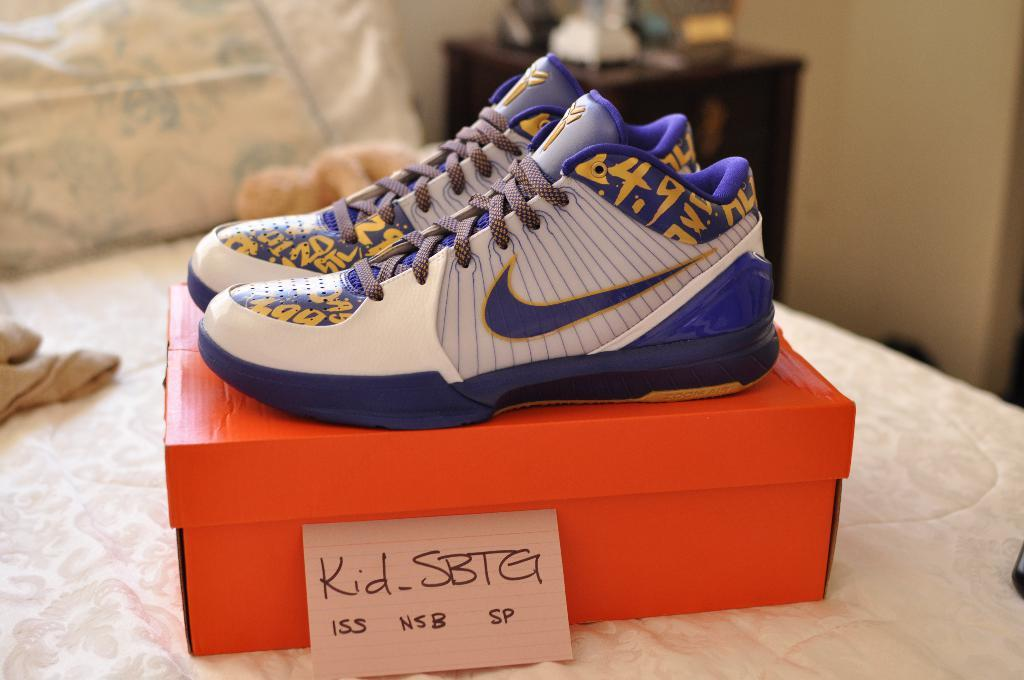What is placed on a box in the image? There is a pair of shoes on a box in the image. What color are the shoes? The shoes are red. What piece of furniture is present in the image? There is a bed, a table, and a wall in the image. What is on the bed? There is a pillow on the bed. What is on the table? There are objects on the table. What time of day does the loaf appear in the image? There is no loaf present in the image, so it cannot appear at any time of day. 